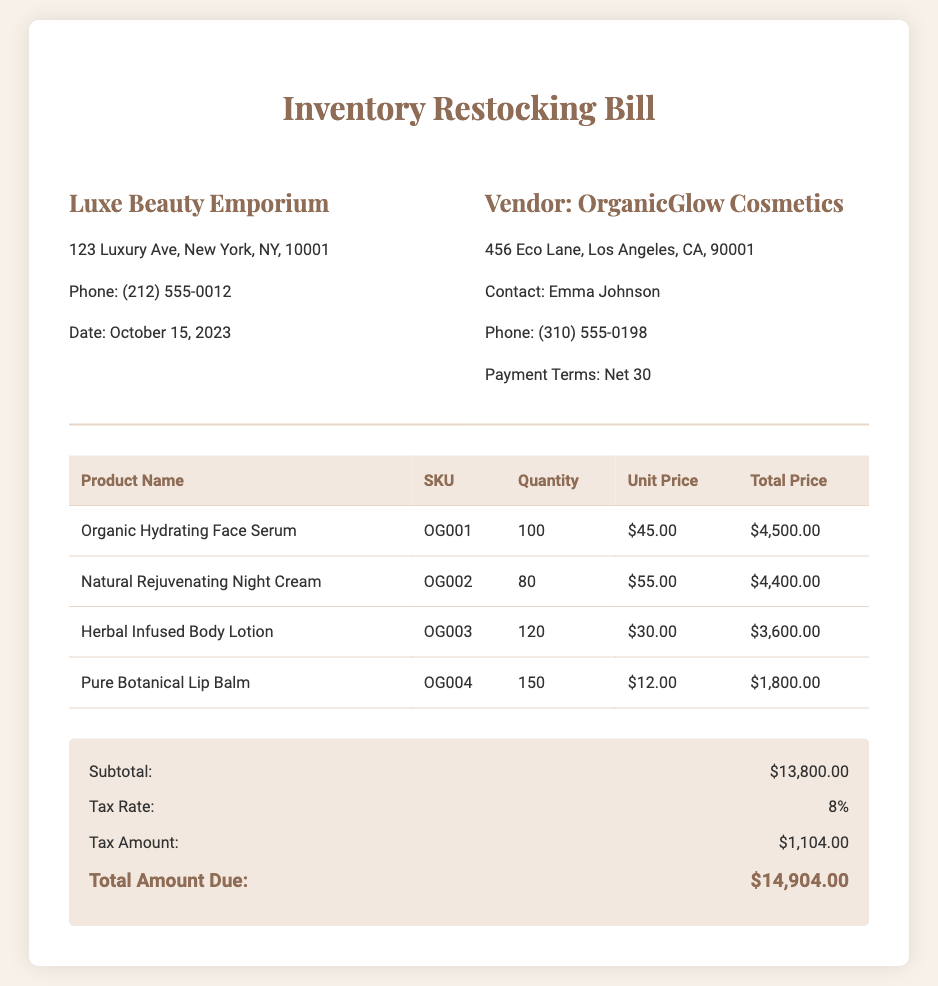What is the store name? The store name is listed at the top of the document, indicating the issuing entity of the bill.
Answer: Luxe Beauty Emporium What is the date of the bill? The date is clearly mentioned under the store information section, marking when the transaction took place.
Answer: October 15, 2023 Who is the vendor? The vendor is specified in the vendor information section, indicating the supplier of the products listed.
Answer: OrganicGlow Cosmetics What is the tax rate? The tax rate is provided in the summary section, indicating the percentage applied to the subtotal for tax calculation.
Answer: 8% What is the total amount due? The total amount due is shown in the summary section, representing the final payment needed after tax is added to the subtotal.
Answer: $14,904.00 How many units of Pure Botanical Lip Balm were ordered? The quantity of each product is specified in the table, indicating how many units of each were requested.
Answer: 150 What is the unit price of Organic Hydrating Face Serum? The unit price is found in the product pricing table, detailing the cost per individual item.
Answer: $45.00 What is the subtotal before tax? The subtotal is located in the summary section and represents the total of all product costs prior to adding tax.
Answer: $13,800.00 What is the contact information for the vendor? The contact information includes the name and phone number provided in the vendor information section for reaching out to the vendor.
Answer: Emma Johnson, (310) 555-0198 